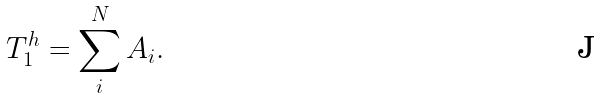Convert formula to latex. <formula><loc_0><loc_0><loc_500><loc_500>T _ { 1 } ^ { h } = \sum _ { i } ^ { N } A _ { i } .</formula> 